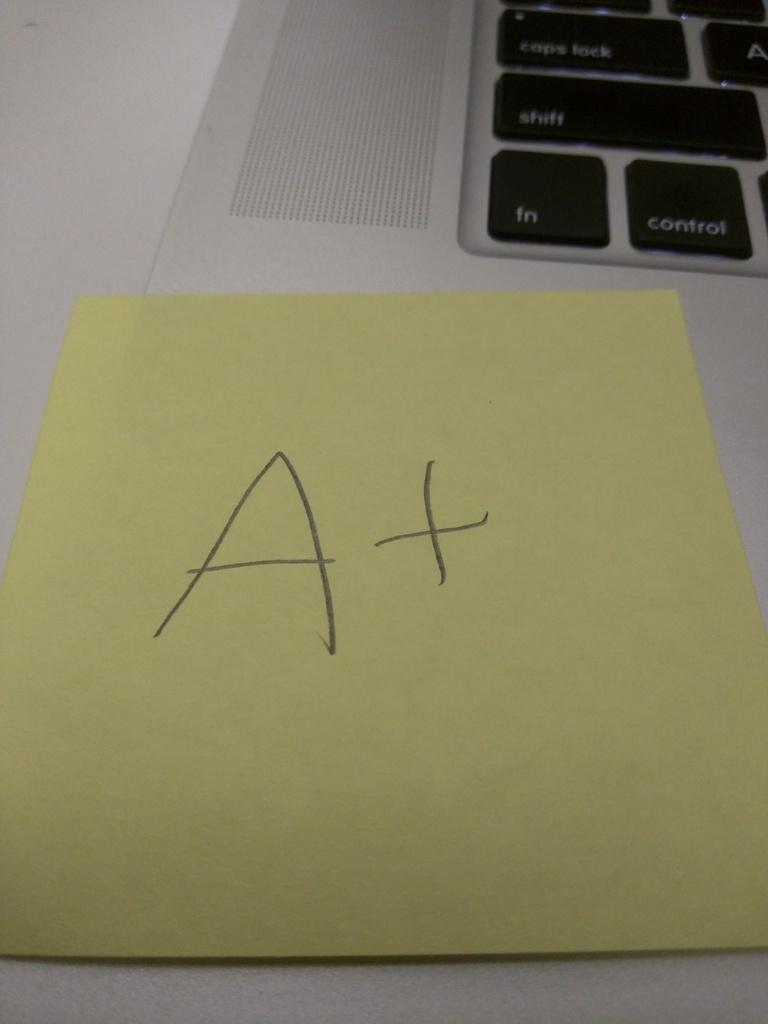Provide a one-sentence caption for the provided image. A sticky note that says A+ stuck onto a macbook. 